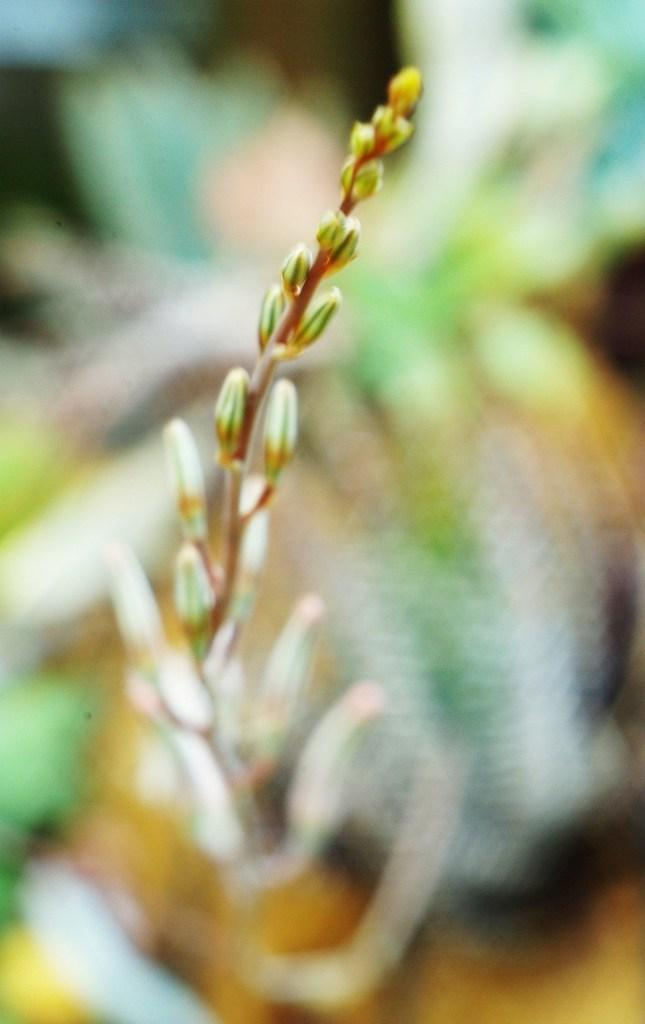What type of living organism can be seen in the image? There is a plant in the image. What type of elbow is visible on the plant in the image? There is no elbow present in the image, as it features a plant, which is a living organism and does not have elbows. 